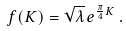<formula> <loc_0><loc_0><loc_500><loc_500>f ( K ) = \sqrt { \lambda } \, e ^ { \frac { \pi } { 4 } K } \, .</formula> 